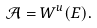<formula> <loc_0><loc_0><loc_500><loc_500>\mathcal { A } = W ^ { u } ( E ) .</formula> 